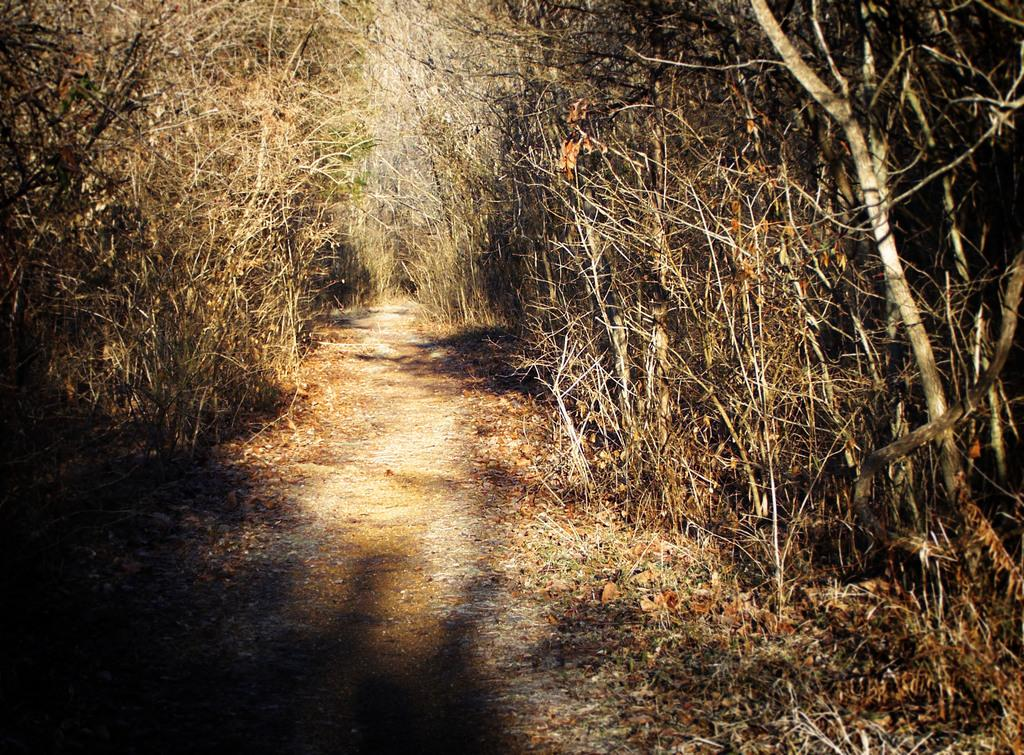What type of vegetation can be seen in the image? There are trees in the image. What is located in the middle of the image? There is a walkway in the middle of the image. How many quarters can be seen on the walkway in the image? There are no quarters present on the walkway in the image. What emotion is depicted by the trees in the image? The trees in the image do not depict any emotions; they are inanimate objects. 